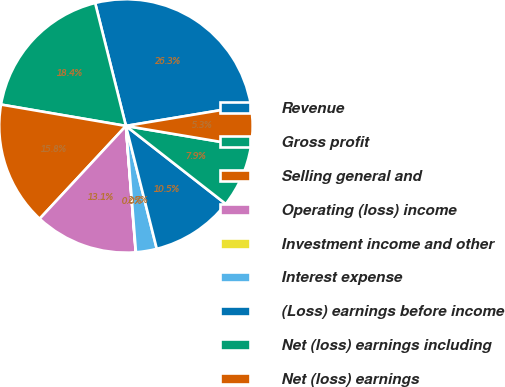<chart> <loc_0><loc_0><loc_500><loc_500><pie_chart><fcel>Revenue<fcel>Gross profit<fcel>Selling general and<fcel>Operating (loss) income<fcel>Investment income and other<fcel>Interest expense<fcel>(Loss) earnings before income<fcel>Net (loss) earnings including<fcel>Net (loss) earnings<nl><fcel>26.28%<fcel>18.4%<fcel>15.78%<fcel>13.15%<fcel>0.03%<fcel>2.65%<fcel>10.53%<fcel>7.9%<fcel>5.28%<nl></chart> 